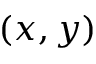<formula> <loc_0><loc_0><loc_500><loc_500>( x , y )</formula> 